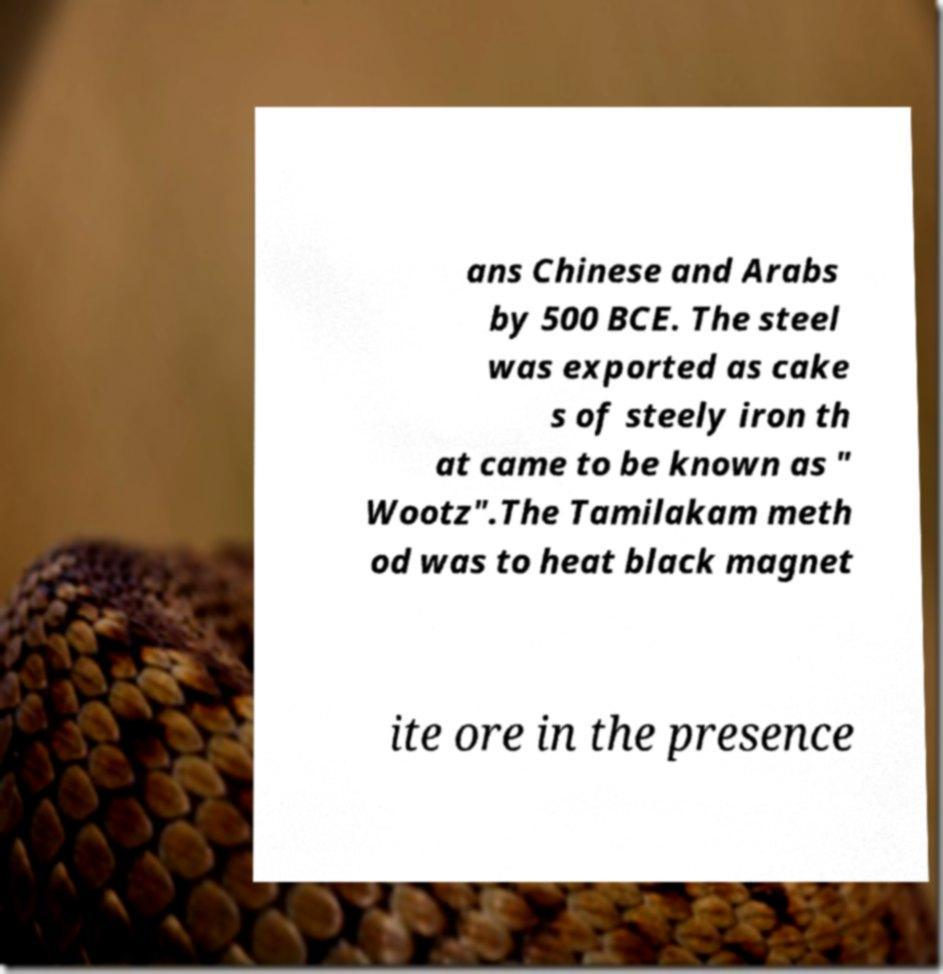Could you extract and type out the text from this image? ans Chinese and Arabs by 500 BCE. The steel was exported as cake s of steely iron th at came to be known as " Wootz".The Tamilakam meth od was to heat black magnet ite ore in the presence 